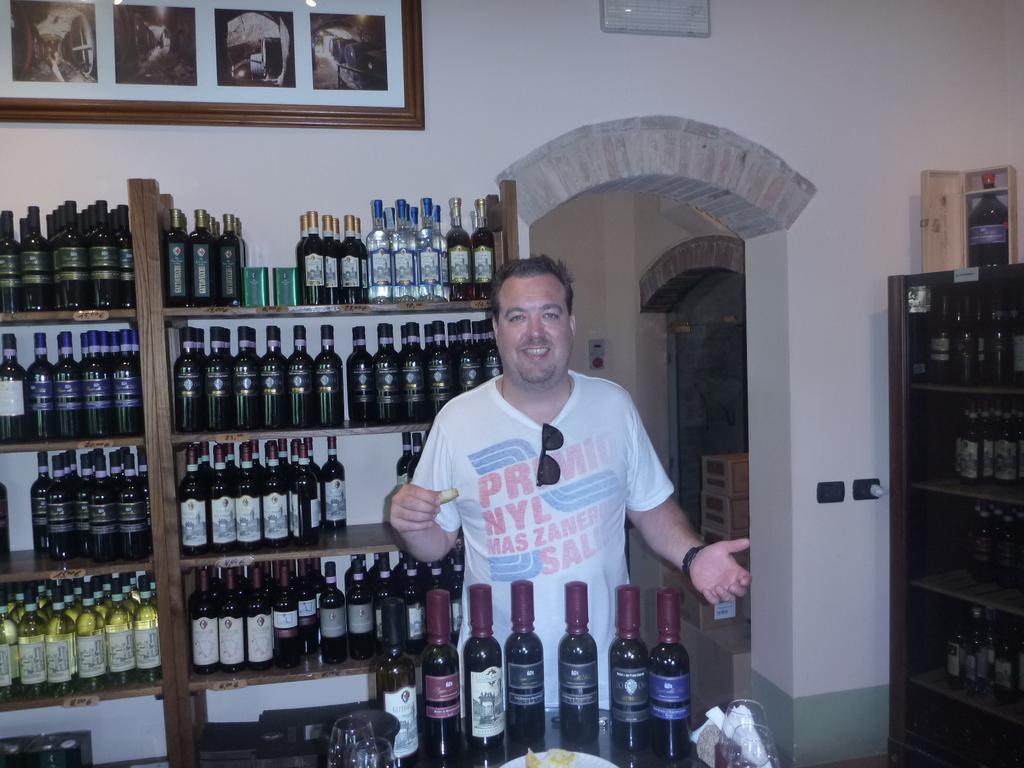What are the 3 letters on the second line of his shirt?
Keep it short and to the point. Nyl. 